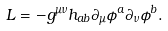Convert formula to latex. <formula><loc_0><loc_0><loc_500><loc_500>L = - g ^ { \mu \nu } h _ { a b } \partial _ { \mu } \phi ^ { a } \partial _ { \nu } \phi ^ { b } .</formula> 